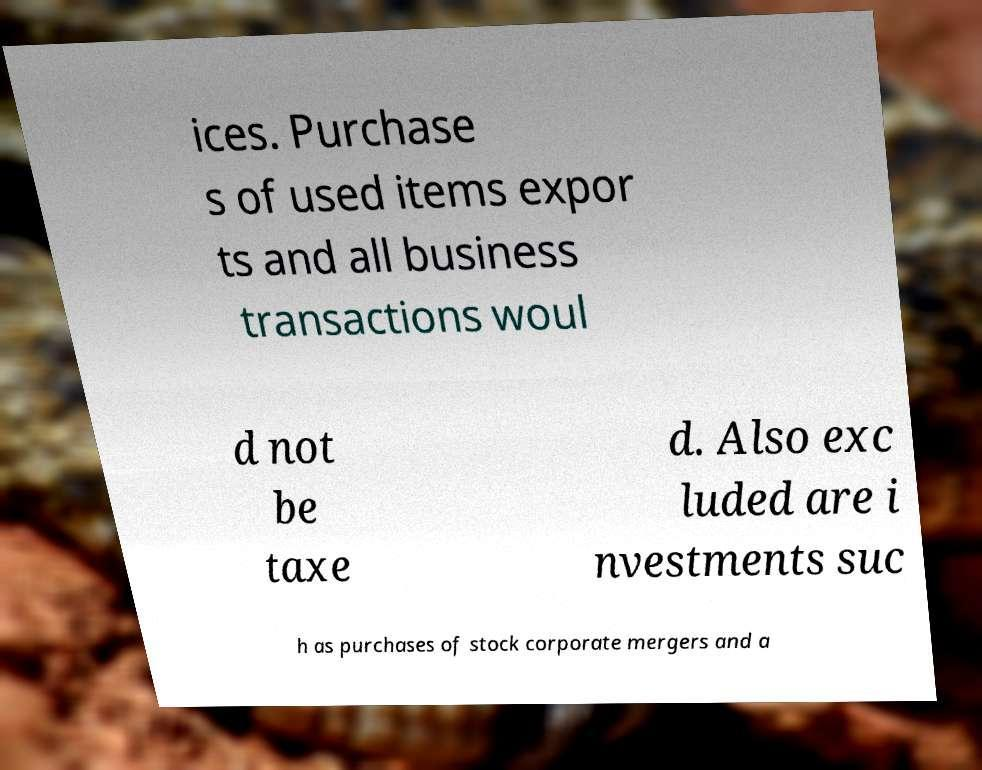Can you read and provide the text displayed in the image?This photo seems to have some interesting text. Can you extract and type it out for me? ices. Purchase s of used items expor ts and all business transactions woul d not be taxe d. Also exc luded are i nvestments suc h as purchases of stock corporate mergers and a 